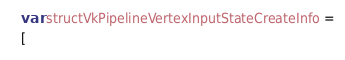Convert code to text. <code><loc_0><loc_0><loc_500><loc_500><_JavaScript_>var structVkPipelineVertexInputStateCreateInfo =
[</code> 